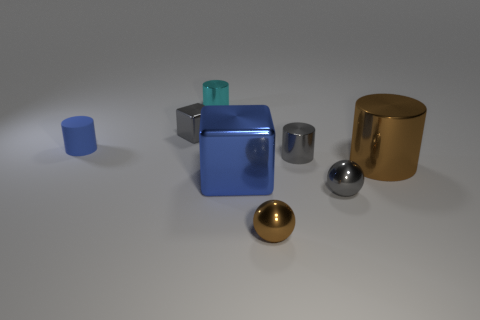Can you describe the material and shape of the object on the far left? The object on the far left is cylindrical with a flat top, resembling a cup or container. It has a matte finish and a consistent, solid blue color which suggests it could be made of plastic or painted ceramic. 